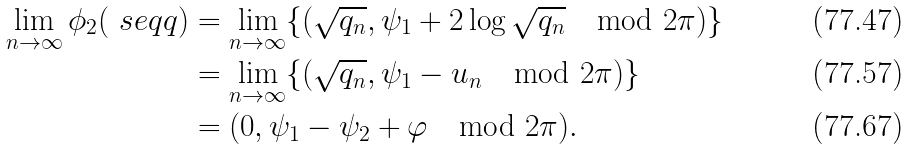Convert formula to latex. <formula><loc_0><loc_0><loc_500><loc_500>\lim _ { n \to \infty } \phi _ { 2 } ( \ s e q q ) & = \lim _ { n \to \infty } \{ ( \sqrt { q _ { n } } , \psi _ { 1 } + 2 \log \sqrt { q _ { n } } \mod 2 \pi ) \} \\ & = \lim _ { n \to \infty } \{ ( \sqrt { q _ { n } } , \psi _ { 1 } - { u _ { n } } \mod 2 \pi ) \} \\ & = ( 0 , \psi _ { 1 } - \psi _ { 2 } + \varphi \mod 2 \pi ) .</formula> 